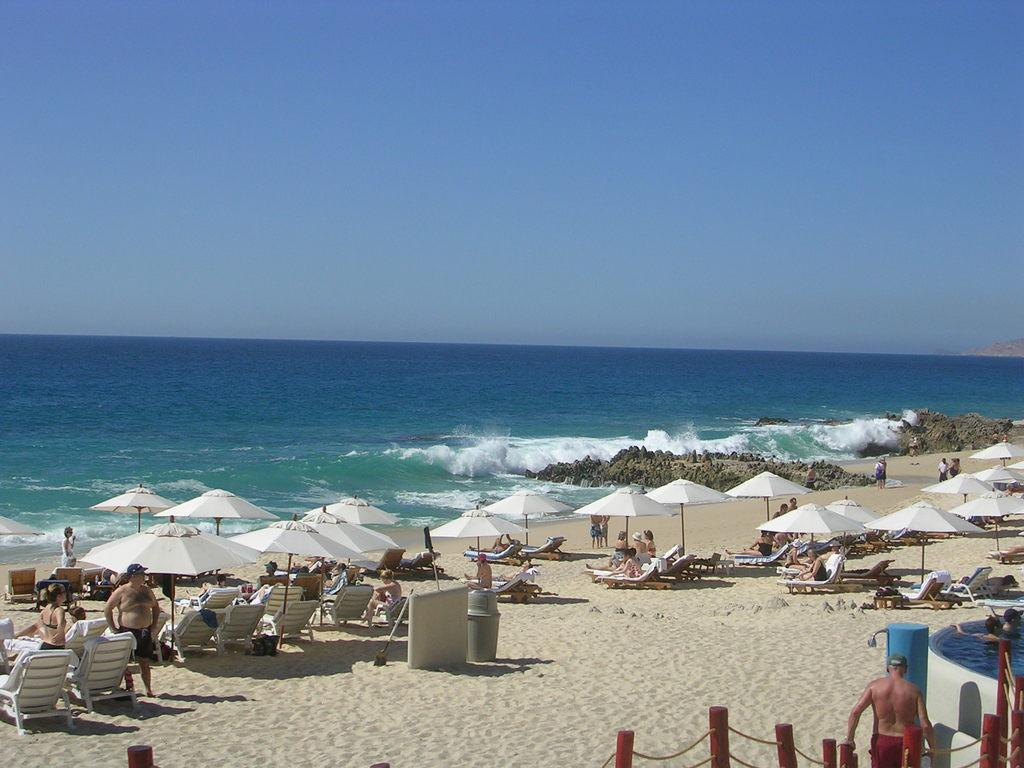What type of location is depicted in the image? The image shows a beach view. What can be seen on the beach? There are white umbrellas and relaxing chairs on the beach. Are there any people in the image? Yes, some people are sitting on the chairs. What can be seen in the background of the image? There is a blue sea visible in the background. What is visible at the top of the image? The sky is visible at the top of the image. What type of rings are being used for the feast in the image? There is no feast or rings present in the image; it shows a beach view with people sitting on chairs. How many tomatoes are being served at the beach feast in the image? There is no feast or tomatoes present in the image; it shows a beach view with people sitting on chairs. 